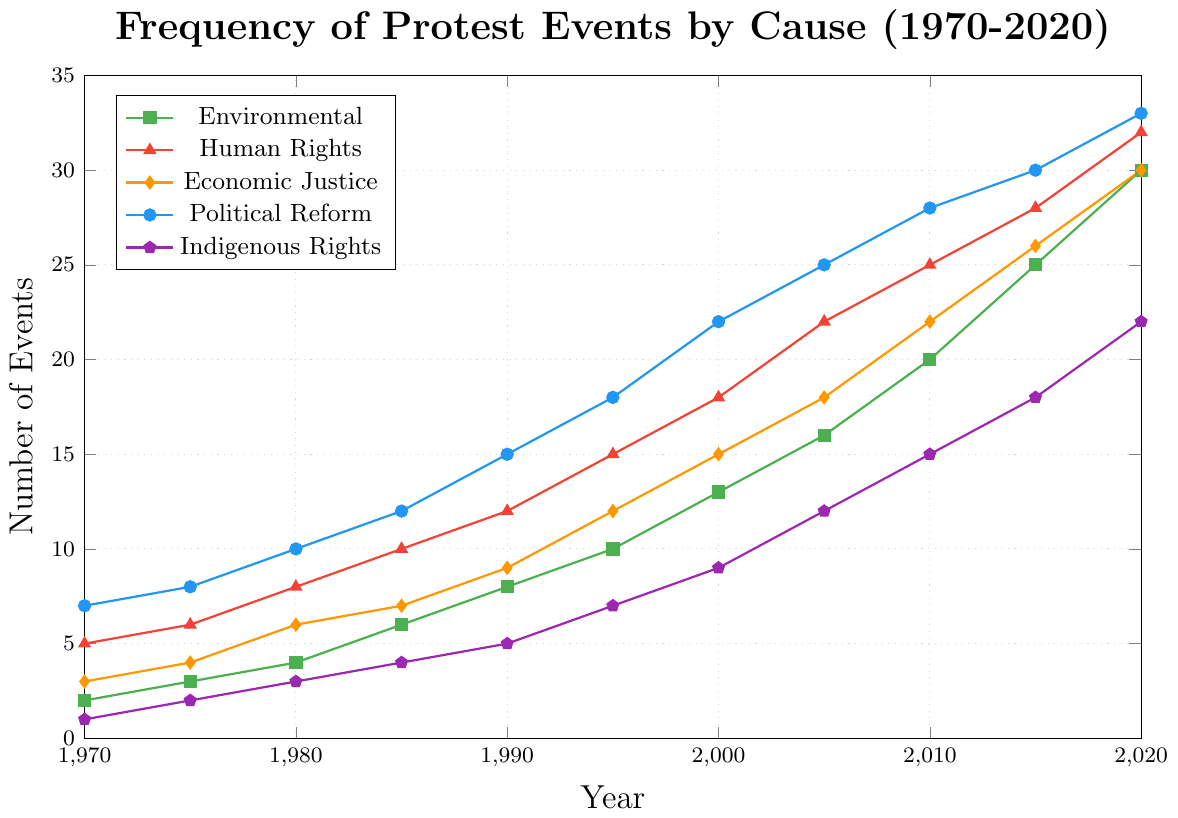Which cause had the highest number of protest events in 2020? Look at the chart to find the highest point in 2020. Political Reform has the highest value at 33 events.
Answer: Political Reform Which cause had the lowest number of protest events in 1970? Look at the chart to find the lowest point in 1970. Indigenous Rights has the lowest value at 1 event.
Answer: Indigenous Rights What is the total number of protest events across all causes in 1990? Sum the numbers of protest events for each cause in 1990: 8 (Environmental) + 12 (Human Rights) + 9 (Economic Justice) + 15 (Political Reform) + 5 (Indigenous Rights) = 49.
Answer: 49 How has the frequency of Environmental protests changed from 1970 to 2020? Compare the number of Environmental protest events in 1970 and 2020: 2 events in 1970 and 30 events in 2020. The number has increased by 28 events.
Answer: Increased by 28 Which year saw the highest number of Economic Justice protest events, and what was the number? Identify the highest point for the Economic Justice line on the chart. In 2020, the number of Economic Justice protest events was the highest at 30.
Answer: 2020 In 2010, how many more Political Reform protests were there compared to Indigenous Rights protests? Find the number of Political Reform protests in 2010 (28) and Indigenous Rights protests in 2010 (15), and calculate the difference: 28 - 15 = 13.
Answer: 13 Which cause showed a consistent increase every five years from 1970 to 2020? Inspect each line in the chart. All causes show a consistent increase, but Political Reform is an example of a cause with a consistent increase every five years.
Answer: Political Reform How did protests for Indigenous Rights change between 1980 and 2000? Compare the number of protest events in 1980 (3) and 2000 (9). The number increased by 6 events.
Answer: Increased by 6 What is the average number of Human Rights protest events per decade from 1970 to 2020? Calculate the average for each decade and then across the entire period: Across 11 data points (5, 6, 8, 10, 12, 15, 18, 22, 25, 28, 32), sum = 181. Average = 181/11 ≈ 16.45.
Answer: Approximately 16.45 Between which two consecutive years did Economic Justice protests see the largest increase? Compare the differences between each consecutive year's values: (4-3, 6-4, 7-6, 9-7, 12-9, 15-12, 18-15, 22-18, 26-22, 30-26). The largest increase is between 2000 and 2005 (18-15 = 3).
Answer: 2000 to 2005 